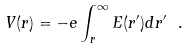<formula> <loc_0><loc_0><loc_500><loc_500>V ( r ) = - e \int _ { r } ^ { \infty } E ( r ^ { \prime } ) d r ^ { \prime } \ .</formula> 